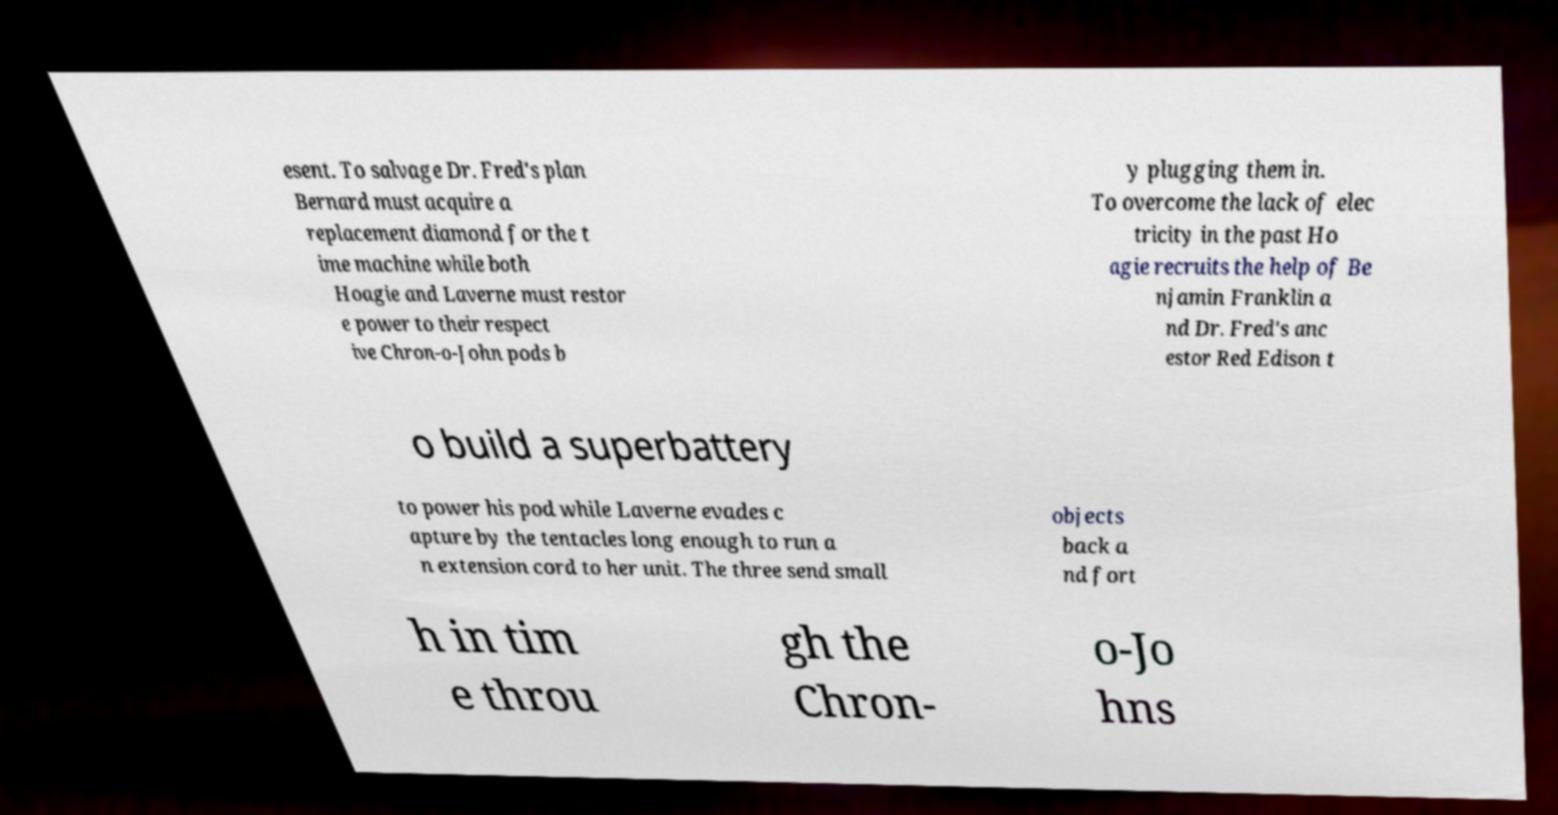Could you extract and type out the text from this image? esent. To salvage Dr. Fred's plan Bernard must acquire a replacement diamond for the t ime machine while both Hoagie and Laverne must restor e power to their respect ive Chron-o-John pods b y plugging them in. To overcome the lack of elec tricity in the past Ho agie recruits the help of Be njamin Franklin a nd Dr. Fred's anc estor Red Edison t o build a superbattery to power his pod while Laverne evades c apture by the tentacles long enough to run a n extension cord to her unit. The three send small objects back a nd fort h in tim e throu gh the Chron- o-Jo hns 